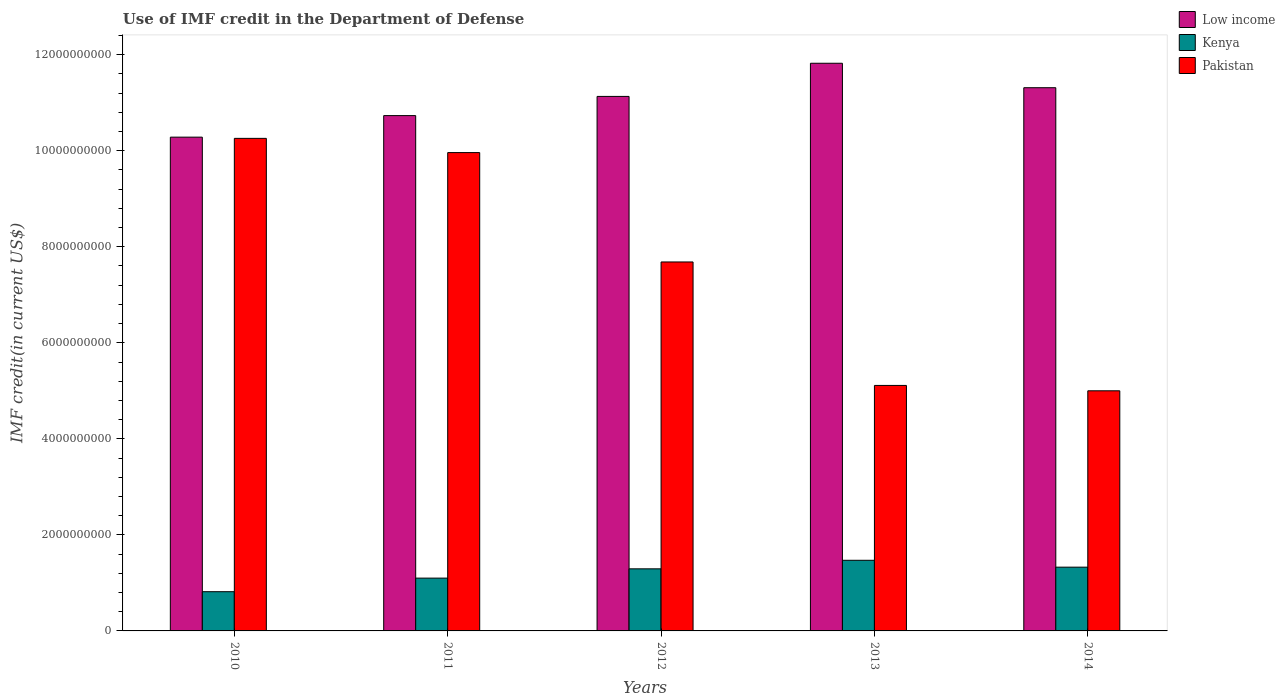Are the number of bars per tick equal to the number of legend labels?
Provide a short and direct response. Yes. Are the number of bars on each tick of the X-axis equal?
Offer a very short reply. Yes. How many bars are there on the 4th tick from the left?
Provide a succinct answer. 3. What is the label of the 5th group of bars from the left?
Ensure brevity in your answer.  2014. In how many cases, is the number of bars for a given year not equal to the number of legend labels?
Make the answer very short. 0. What is the IMF credit in the Department of Defense in Kenya in 2014?
Keep it short and to the point. 1.33e+09. Across all years, what is the maximum IMF credit in the Department of Defense in Pakistan?
Your answer should be very brief. 1.03e+1. Across all years, what is the minimum IMF credit in the Department of Defense in Low income?
Your response must be concise. 1.03e+1. In which year was the IMF credit in the Department of Defense in Pakistan maximum?
Give a very brief answer. 2010. In which year was the IMF credit in the Department of Defense in Kenya minimum?
Provide a short and direct response. 2010. What is the total IMF credit in the Department of Defense in Low income in the graph?
Offer a terse response. 5.53e+1. What is the difference between the IMF credit in the Department of Defense in Low income in 2011 and that in 2014?
Your response must be concise. -5.81e+08. What is the difference between the IMF credit in the Department of Defense in Kenya in 2010 and the IMF credit in the Department of Defense in Low income in 2014?
Your answer should be compact. -1.05e+1. What is the average IMF credit in the Department of Defense in Low income per year?
Offer a very short reply. 1.11e+1. In the year 2012, what is the difference between the IMF credit in the Department of Defense in Pakistan and IMF credit in the Department of Defense in Low income?
Provide a succinct answer. -3.45e+09. What is the ratio of the IMF credit in the Department of Defense in Pakistan in 2010 to that in 2013?
Offer a terse response. 2.01. What is the difference between the highest and the second highest IMF credit in the Department of Defense in Low income?
Ensure brevity in your answer.  5.09e+08. What is the difference between the highest and the lowest IMF credit in the Department of Defense in Kenya?
Provide a succinct answer. 6.54e+08. In how many years, is the IMF credit in the Department of Defense in Pakistan greater than the average IMF credit in the Department of Defense in Pakistan taken over all years?
Provide a succinct answer. 3. Is the sum of the IMF credit in the Department of Defense in Low income in 2012 and 2013 greater than the maximum IMF credit in the Department of Defense in Kenya across all years?
Make the answer very short. Yes. What does the 2nd bar from the left in 2010 represents?
Offer a very short reply. Kenya. What does the 2nd bar from the right in 2013 represents?
Make the answer very short. Kenya. Is it the case that in every year, the sum of the IMF credit in the Department of Defense in Pakistan and IMF credit in the Department of Defense in Kenya is greater than the IMF credit in the Department of Defense in Low income?
Provide a short and direct response. No. How many years are there in the graph?
Keep it short and to the point. 5. What is the difference between two consecutive major ticks on the Y-axis?
Your response must be concise. 2.00e+09. Does the graph contain any zero values?
Keep it short and to the point. No. Does the graph contain grids?
Ensure brevity in your answer.  No. Where does the legend appear in the graph?
Your response must be concise. Top right. How many legend labels are there?
Give a very brief answer. 3. How are the legend labels stacked?
Give a very brief answer. Vertical. What is the title of the graph?
Provide a short and direct response. Use of IMF credit in the Department of Defense. Does "Barbados" appear as one of the legend labels in the graph?
Give a very brief answer. No. What is the label or title of the Y-axis?
Ensure brevity in your answer.  IMF credit(in current US$). What is the IMF credit(in current US$) of Low income in 2010?
Provide a succinct answer. 1.03e+1. What is the IMF credit(in current US$) in Kenya in 2010?
Provide a short and direct response. 8.17e+08. What is the IMF credit(in current US$) of Pakistan in 2010?
Provide a succinct answer. 1.03e+1. What is the IMF credit(in current US$) of Low income in 2011?
Offer a terse response. 1.07e+1. What is the IMF credit(in current US$) of Kenya in 2011?
Keep it short and to the point. 1.10e+09. What is the IMF credit(in current US$) of Pakistan in 2011?
Ensure brevity in your answer.  9.96e+09. What is the IMF credit(in current US$) in Low income in 2012?
Make the answer very short. 1.11e+1. What is the IMF credit(in current US$) of Kenya in 2012?
Offer a terse response. 1.29e+09. What is the IMF credit(in current US$) of Pakistan in 2012?
Keep it short and to the point. 7.68e+09. What is the IMF credit(in current US$) in Low income in 2013?
Make the answer very short. 1.18e+1. What is the IMF credit(in current US$) of Kenya in 2013?
Your answer should be compact. 1.47e+09. What is the IMF credit(in current US$) in Pakistan in 2013?
Your answer should be compact. 5.11e+09. What is the IMF credit(in current US$) in Low income in 2014?
Give a very brief answer. 1.13e+1. What is the IMF credit(in current US$) in Kenya in 2014?
Provide a succinct answer. 1.33e+09. What is the IMF credit(in current US$) in Pakistan in 2014?
Your answer should be compact. 5.00e+09. Across all years, what is the maximum IMF credit(in current US$) of Low income?
Offer a very short reply. 1.18e+1. Across all years, what is the maximum IMF credit(in current US$) in Kenya?
Your answer should be compact. 1.47e+09. Across all years, what is the maximum IMF credit(in current US$) of Pakistan?
Provide a succinct answer. 1.03e+1. Across all years, what is the minimum IMF credit(in current US$) in Low income?
Make the answer very short. 1.03e+1. Across all years, what is the minimum IMF credit(in current US$) of Kenya?
Give a very brief answer. 8.17e+08. Across all years, what is the minimum IMF credit(in current US$) in Pakistan?
Provide a short and direct response. 5.00e+09. What is the total IMF credit(in current US$) in Low income in the graph?
Give a very brief answer. 5.53e+1. What is the total IMF credit(in current US$) in Kenya in the graph?
Provide a short and direct response. 6.01e+09. What is the total IMF credit(in current US$) of Pakistan in the graph?
Give a very brief answer. 3.80e+1. What is the difference between the IMF credit(in current US$) in Low income in 2010 and that in 2011?
Offer a very short reply. -4.49e+08. What is the difference between the IMF credit(in current US$) in Kenya in 2010 and that in 2011?
Your answer should be compact. -2.83e+08. What is the difference between the IMF credit(in current US$) of Pakistan in 2010 and that in 2011?
Your response must be concise. 2.96e+08. What is the difference between the IMF credit(in current US$) of Low income in 2010 and that in 2012?
Offer a terse response. -8.48e+08. What is the difference between the IMF credit(in current US$) of Kenya in 2010 and that in 2012?
Your answer should be compact. -4.76e+08. What is the difference between the IMF credit(in current US$) in Pakistan in 2010 and that in 2012?
Your answer should be compact. 2.57e+09. What is the difference between the IMF credit(in current US$) of Low income in 2010 and that in 2013?
Your answer should be compact. -1.54e+09. What is the difference between the IMF credit(in current US$) in Kenya in 2010 and that in 2013?
Provide a short and direct response. -6.54e+08. What is the difference between the IMF credit(in current US$) of Pakistan in 2010 and that in 2013?
Your response must be concise. 5.15e+09. What is the difference between the IMF credit(in current US$) of Low income in 2010 and that in 2014?
Provide a short and direct response. -1.03e+09. What is the difference between the IMF credit(in current US$) of Kenya in 2010 and that in 2014?
Your answer should be compact. -5.11e+08. What is the difference between the IMF credit(in current US$) in Pakistan in 2010 and that in 2014?
Keep it short and to the point. 5.26e+09. What is the difference between the IMF credit(in current US$) of Low income in 2011 and that in 2012?
Your response must be concise. -4.00e+08. What is the difference between the IMF credit(in current US$) of Kenya in 2011 and that in 2012?
Your answer should be very brief. -1.93e+08. What is the difference between the IMF credit(in current US$) of Pakistan in 2011 and that in 2012?
Ensure brevity in your answer.  2.28e+09. What is the difference between the IMF credit(in current US$) in Low income in 2011 and that in 2013?
Provide a succinct answer. -1.09e+09. What is the difference between the IMF credit(in current US$) in Kenya in 2011 and that in 2013?
Provide a succinct answer. -3.71e+08. What is the difference between the IMF credit(in current US$) in Pakistan in 2011 and that in 2013?
Provide a short and direct response. 4.85e+09. What is the difference between the IMF credit(in current US$) in Low income in 2011 and that in 2014?
Your answer should be very brief. -5.81e+08. What is the difference between the IMF credit(in current US$) of Kenya in 2011 and that in 2014?
Your answer should be very brief. -2.28e+08. What is the difference between the IMF credit(in current US$) of Pakistan in 2011 and that in 2014?
Provide a succinct answer. 4.96e+09. What is the difference between the IMF credit(in current US$) of Low income in 2012 and that in 2013?
Your response must be concise. -6.91e+08. What is the difference between the IMF credit(in current US$) in Kenya in 2012 and that in 2013?
Provide a short and direct response. -1.78e+08. What is the difference between the IMF credit(in current US$) of Pakistan in 2012 and that in 2013?
Your answer should be very brief. 2.57e+09. What is the difference between the IMF credit(in current US$) in Low income in 2012 and that in 2014?
Your answer should be very brief. -1.81e+08. What is the difference between the IMF credit(in current US$) in Kenya in 2012 and that in 2014?
Your answer should be compact. -3.49e+07. What is the difference between the IMF credit(in current US$) in Pakistan in 2012 and that in 2014?
Your response must be concise. 2.68e+09. What is the difference between the IMF credit(in current US$) in Low income in 2013 and that in 2014?
Make the answer very short. 5.09e+08. What is the difference between the IMF credit(in current US$) in Kenya in 2013 and that in 2014?
Ensure brevity in your answer.  1.43e+08. What is the difference between the IMF credit(in current US$) in Pakistan in 2013 and that in 2014?
Keep it short and to the point. 1.12e+08. What is the difference between the IMF credit(in current US$) in Low income in 2010 and the IMF credit(in current US$) in Kenya in 2011?
Give a very brief answer. 9.18e+09. What is the difference between the IMF credit(in current US$) in Low income in 2010 and the IMF credit(in current US$) in Pakistan in 2011?
Provide a short and direct response. 3.21e+08. What is the difference between the IMF credit(in current US$) of Kenya in 2010 and the IMF credit(in current US$) of Pakistan in 2011?
Give a very brief answer. -9.15e+09. What is the difference between the IMF credit(in current US$) of Low income in 2010 and the IMF credit(in current US$) of Kenya in 2012?
Give a very brief answer. 8.99e+09. What is the difference between the IMF credit(in current US$) of Low income in 2010 and the IMF credit(in current US$) of Pakistan in 2012?
Provide a succinct answer. 2.60e+09. What is the difference between the IMF credit(in current US$) in Kenya in 2010 and the IMF credit(in current US$) in Pakistan in 2012?
Make the answer very short. -6.87e+09. What is the difference between the IMF credit(in current US$) of Low income in 2010 and the IMF credit(in current US$) of Kenya in 2013?
Your response must be concise. 8.81e+09. What is the difference between the IMF credit(in current US$) of Low income in 2010 and the IMF credit(in current US$) of Pakistan in 2013?
Your response must be concise. 5.17e+09. What is the difference between the IMF credit(in current US$) of Kenya in 2010 and the IMF credit(in current US$) of Pakistan in 2013?
Give a very brief answer. -4.30e+09. What is the difference between the IMF credit(in current US$) of Low income in 2010 and the IMF credit(in current US$) of Kenya in 2014?
Your answer should be very brief. 8.96e+09. What is the difference between the IMF credit(in current US$) of Low income in 2010 and the IMF credit(in current US$) of Pakistan in 2014?
Offer a terse response. 5.28e+09. What is the difference between the IMF credit(in current US$) of Kenya in 2010 and the IMF credit(in current US$) of Pakistan in 2014?
Ensure brevity in your answer.  -4.18e+09. What is the difference between the IMF credit(in current US$) of Low income in 2011 and the IMF credit(in current US$) of Kenya in 2012?
Give a very brief answer. 9.44e+09. What is the difference between the IMF credit(in current US$) in Low income in 2011 and the IMF credit(in current US$) in Pakistan in 2012?
Your answer should be very brief. 3.05e+09. What is the difference between the IMF credit(in current US$) in Kenya in 2011 and the IMF credit(in current US$) in Pakistan in 2012?
Provide a succinct answer. -6.58e+09. What is the difference between the IMF credit(in current US$) of Low income in 2011 and the IMF credit(in current US$) of Kenya in 2013?
Offer a terse response. 9.26e+09. What is the difference between the IMF credit(in current US$) of Low income in 2011 and the IMF credit(in current US$) of Pakistan in 2013?
Offer a terse response. 5.62e+09. What is the difference between the IMF credit(in current US$) in Kenya in 2011 and the IMF credit(in current US$) in Pakistan in 2013?
Your answer should be very brief. -4.01e+09. What is the difference between the IMF credit(in current US$) in Low income in 2011 and the IMF credit(in current US$) in Kenya in 2014?
Offer a terse response. 9.40e+09. What is the difference between the IMF credit(in current US$) in Low income in 2011 and the IMF credit(in current US$) in Pakistan in 2014?
Offer a terse response. 5.73e+09. What is the difference between the IMF credit(in current US$) in Kenya in 2011 and the IMF credit(in current US$) in Pakistan in 2014?
Keep it short and to the point. -3.90e+09. What is the difference between the IMF credit(in current US$) of Low income in 2012 and the IMF credit(in current US$) of Kenya in 2013?
Ensure brevity in your answer.  9.66e+09. What is the difference between the IMF credit(in current US$) in Low income in 2012 and the IMF credit(in current US$) in Pakistan in 2013?
Your response must be concise. 6.02e+09. What is the difference between the IMF credit(in current US$) in Kenya in 2012 and the IMF credit(in current US$) in Pakistan in 2013?
Make the answer very short. -3.82e+09. What is the difference between the IMF credit(in current US$) in Low income in 2012 and the IMF credit(in current US$) in Kenya in 2014?
Your answer should be very brief. 9.80e+09. What is the difference between the IMF credit(in current US$) of Low income in 2012 and the IMF credit(in current US$) of Pakistan in 2014?
Provide a short and direct response. 6.13e+09. What is the difference between the IMF credit(in current US$) of Kenya in 2012 and the IMF credit(in current US$) of Pakistan in 2014?
Your answer should be very brief. -3.71e+09. What is the difference between the IMF credit(in current US$) in Low income in 2013 and the IMF credit(in current US$) in Kenya in 2014?
Ensure brevity in your answer.  1.05e+1. What is the difference between the IMF credit(in current US$) of Low income in 2013 and the IMF credit(in current US$) of Pakistan in 2014?
Your answer should be compact. 6.82e+09. What is the difference between the IMF credit(in current US$) of Kenya in 2013 and the IMF credit(in current US$) of Pakistan in 2014?
Make the answer very short. -3.53e+09. What is the average IMF credit(in current US$) in Low income per year?
Provide a short and direct response. 1.11e+1. What is the average IMF credit(in current US$) of Kenya per year?
Provide a succinct answer. 1.20e+09. What is the average IMF credit(in current US$) in Pakistan per year?
Offer a very short reply. 7.60e+09. In the year 2010, what is the difference between the IMF credit(in current US$) in Low income and IMF credit(in current US$) in Kenya?
Your response must be concise. 9.47e+09. In the year 2010, what is the difference between the IMF credit(in current US$) in Low income and IMF credit(in current US$) in Pakistan?
Give a very brief answer. 2.51e+07. In the year 2010, what is the difference between the IMF credit(in current US$) in Kenya and IMF credit(in current US$) in Pakistan?
Offer a terse response. -9.44e+09. In the year 2011, what is the difference between the IMF credit(in current US$) in Low income and IMF credit(in current US$) in Kenya?
Give a very brief answer. 9.63e+09. In the year 2011, what is the difference between the IMF credit(in current US$) of Low income and IMF credit(in current US$) of Pakistan?
Offer a very short reply. 7.70e+08. In the year 2011, what is the difference between the IMF credit(in current US$) in Kenya and IMF credit(in current US$) in Pakistan?
Keep it short and to the point. -8.86e+09. In the year 2012, what is the difference between the IMF credit(in current US$) of Low income and IMF credit(in current US$) of Kenya?
Your response must be concise. 9.84e+09. In the year 2012, what is the difference between the IMF credit(in current US$) in Low income and IMF credit(in current US$) in Pakistan?
Your response must be concise. 3.45e+09. In the year 2012, what is the difference between the IMF credit(in current US$) of Kenya and IMF credit(in current US$) of Pakistan?
Provide a succinct answer. -6.39e+09. In the year 2013, what is the difference between the IMF credit(in current US$) of Low income and IMF credit(in current US$) of Kenya?
Provide a short and direct response. 1.04e+1. In the year 2013, what is the difference between the IMF credit(in current US$) in Low income and IMF credit(in current US$) in Pakistan?
Provide a succinct answer. 6.71e+09. In the year 2013, what is the difference between the IMF credit(in current US$) of Kenya and IMF credit(in current US$) of Pakistan?
Your answer should be very brief. -3.64e+09. In the year 2014, what is the difference between the IMF credit(in current US$) of Low income and IMF credit(in current US$) of Kenya?
Make the answer very short. 9.98e+09. In the year 2014, what is the difference between the IMF credit(in current US$) of Low income and IMF credit(in current US$) of Pakistan?
Offer a very short reply. 6.31e+09. In the year 2014, what is the difference between the IMF credit(in current US$) of Kenya and IMF credit(in current US$) of Pakistan?
Your response must be concise. -3.67e+09. What is the ratio of the IMF credit(in current US$) of Low income in 2010 to that in 2011?
Make the answer very short. 0.96. What is the ratio of the IMF credit(in current US$) of Kenya in 2010 to that in 2011?
Offer a terse response. 0.74. What is the ratio of the IMF credit(in current US$) of Pakistan in 2010 to that in 2011?
Your response must be concise. 1.03. What is the ratio of the IMF credit(in current US$) in Low income in 2010 to that in 2012?
Make the answer very short. 0.92. What is the ratio of the IMF credit(in current US$) of Kenya in 2010 to that in 2012?
Your response must be concise. 0.63. What is the ratio of the IMF credit(in current US$) in Pakistan in 2010 to that in 2012?
Provide a short and direct response. 1.33. What is the ratio of the IMF credit(in current US$) in Low income in 2010 to that in 2013?
Keep it short and to the point. 0.87. What is the ratio of the IMF credit(in current US$) in Kenya in 2010 to that in 2013?
Provide a succinct answer. 0.56. What is the ratio of the IMF credit(in current US$) in Pakistan in 2010 to that in 2013?
Ensure brevity in your answer.  2.01. What is the ratio of the IMF credit(in current US$) of Low income in 2010 to that in 2014?
Your answer should be very brief. 0.91. What is the ratio of the IMF credit(in current US$) in Kenya in 2010 to that in 2014?
Make the answer very short. 0.62. What is the ratio of the IMF credit(in current US$) in Pakistan in 2010 to that in 2014?
Keep it short and to the point. 2.05. What is the ratio of the IMF credit(in current US$) in Low income in 2011 to that in 2012?
Your answer should be very brief. 0.96. What is the ratio of the IMF credit(in current US$) in Kenya in 2011 to that in 2012?
Give a very brief answer. 0.85. What is the ratio of the IMF credit(in current US$) of Pakistan in 2011 to that in 2012?
Ensure brevity in your answer.  1.3. What is the ratio of the IMF credit(in current US$) of Low income in 2011 to that in 2013?
Make the answer very short. 0.91. What is the ratio of the IMF credit(in current US$) of Kenya in 2011 to that in 2013?
Provide a short and direct response. 0.75. What is the ratio of the IMF credit(in current US$) in Pakistan in 2011 to that in 2013?
Make the answer very short. 1.95. What is the ratio of the IMF credit(in current US$) in Low income in 2011 to that in 2014?
Offer a terse response. 0.95. What is the ratio of the IMF credit(in current US$) in Kenya in 2011 to that in 2014?
Give a very brief answer. 0.83. What is the ratio of the IMF credit(in current US$) of Pakistan in 2011 to that in 2014?
Offer a very short reply. 1.99. What is the ratio of the IMF credit(in current US$) of Low income in 2012 to that in 2013?
Give a very brief answer. 0.94. What is the ratio of the IMF credit(in current US$) of Kenya in 2012 to that in 2013?
Keep it short and to the point. 0.88. What is the ratio of the IMF credit(in current US$) in Pakistan in 2012 to that in 2013?
Keep it short and to the point. 1.5. What is the ratio of the IMF credit(in current US$) in Kenya in 2012 to that in 2014?
Provide a succinct answer. 0.97. What is the ratio of the IMF credit(in current US$) in Pakistan in 2012 to that in 2014?
Your response must be concise. 1.54. What is the ratio of the IMF credit(in current US$) of Low income in 2013 to that in 2014?
Your answer should be compact. 1.04. What is the ratio of the IMF credit(in current US$) in Kenya in 2013 to that in 2014?
Your response must be concise. 1.11. What is the ratio of the IMF credit(in current US$) in Pakistan in 2013 to that in 2014?
Your answer should be very brief. 1.02. What is the difference between the highest and the second highest IMF credit(in current US$) of Low income?
Provide a succinct answer. 5.09e+08. What is the difference between the highest and the second highest IMF credit(in current US$) in Kenya?
Offer a very short reply. 1.43e+08. What is the difference between the highest and the second highest IMF credit(in current US$) of Pakistan?
Your answer should be compact. 2.96e+08. What is the difference between the highest and the lowest IMF credit(in current US$) of Low income?
Ensure brevity in your answer.  1.54e+09. What is the difference between the highest and the lowest IMF credit(in current US$) of Kenya?
Offer a very short reply. 6.54e+08. What is the difference between the highest and the lowest IMF credit(in current US$) in Pakistan?
Your answer should be compact. 5.26e+09. 